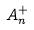Convert formula to latex. <formula><loc_0><loc_0><loc_500><loc_500>A _ { n } ^ { + }</formula> 